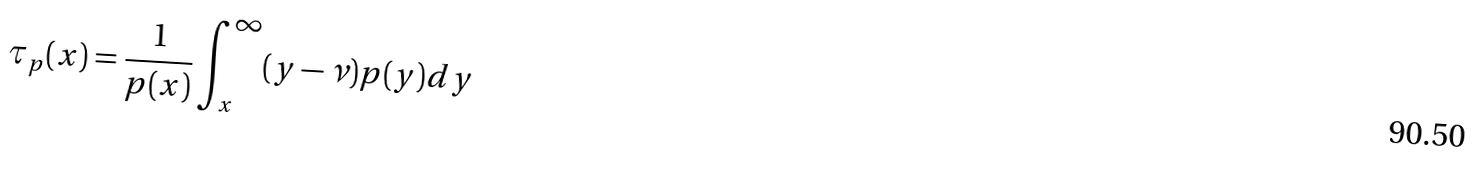Convert formula to latex. <formula><loc_0><loc_0><loc_500><loc_500>\tau _ { p } ( x ) = \frac { 1 } { p ( x ) } \int _ { x } ^ { \infty } ( y - \nu ) p ( y ) d y</formula> 